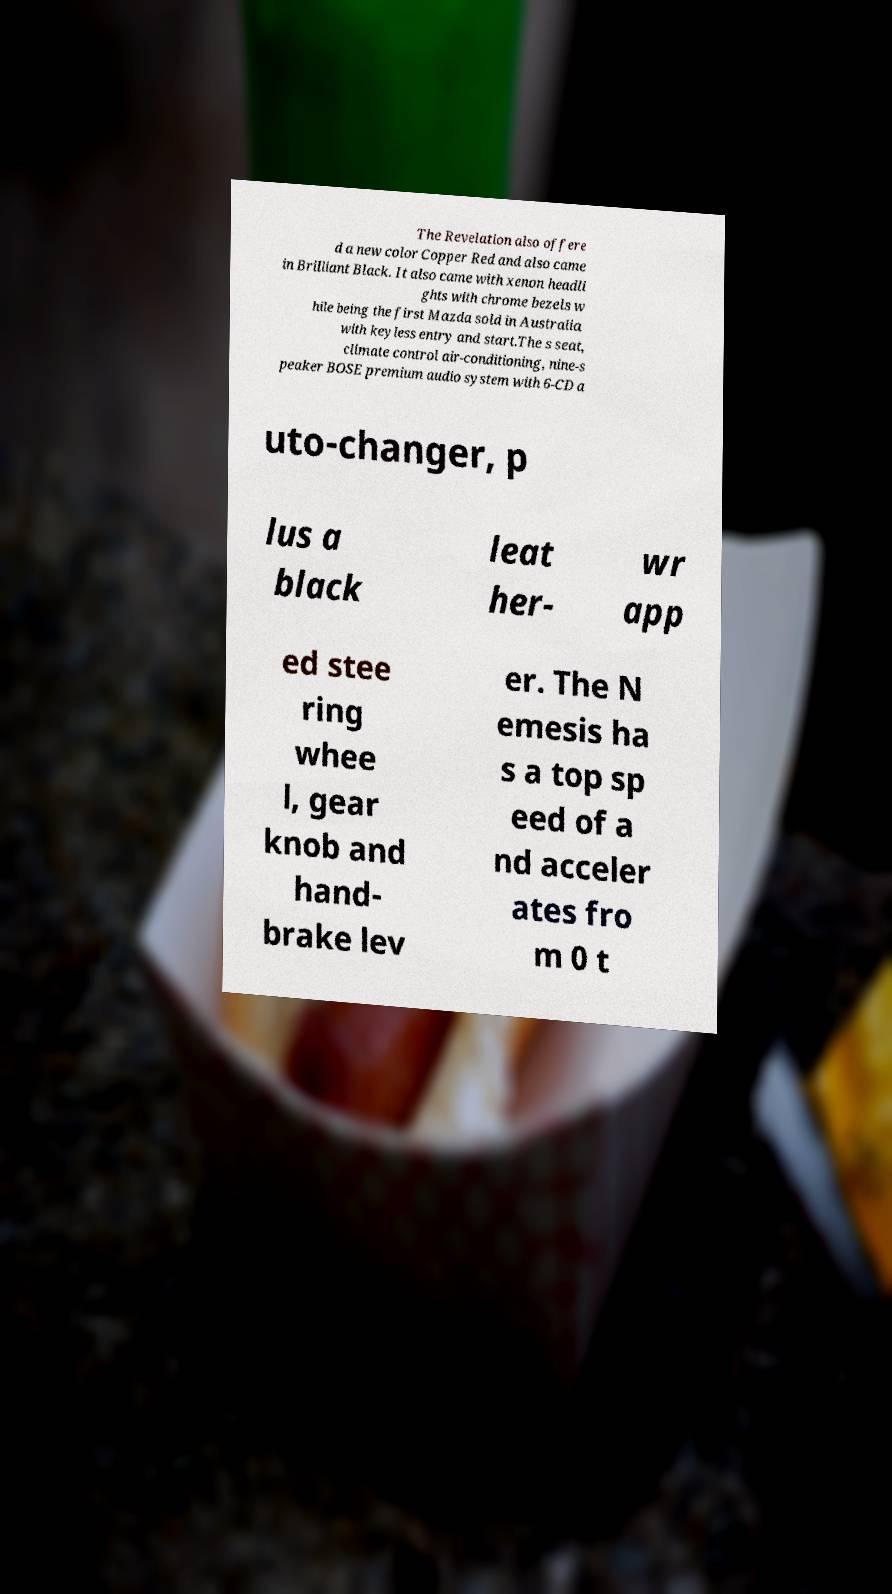Please read and relay the text visible in this image. What does it say? The Revelation also offere d a new color Copper Red and also came in Brilliant Black. It also came with xenon headli ghts with chrome bezels w hile being the first Mazda sold in Australia with keyless entry and start.The s seat, climate control air-conditioning, nine-s peaker BOSE premium audio system with 6-CD a uto-changer, p lus a black leat her- wr app ed stee ring whee l, gear knob and hand- brake lev er. The N emesis ha s a top sp eed of a nd acceler ates fro m 0 t 